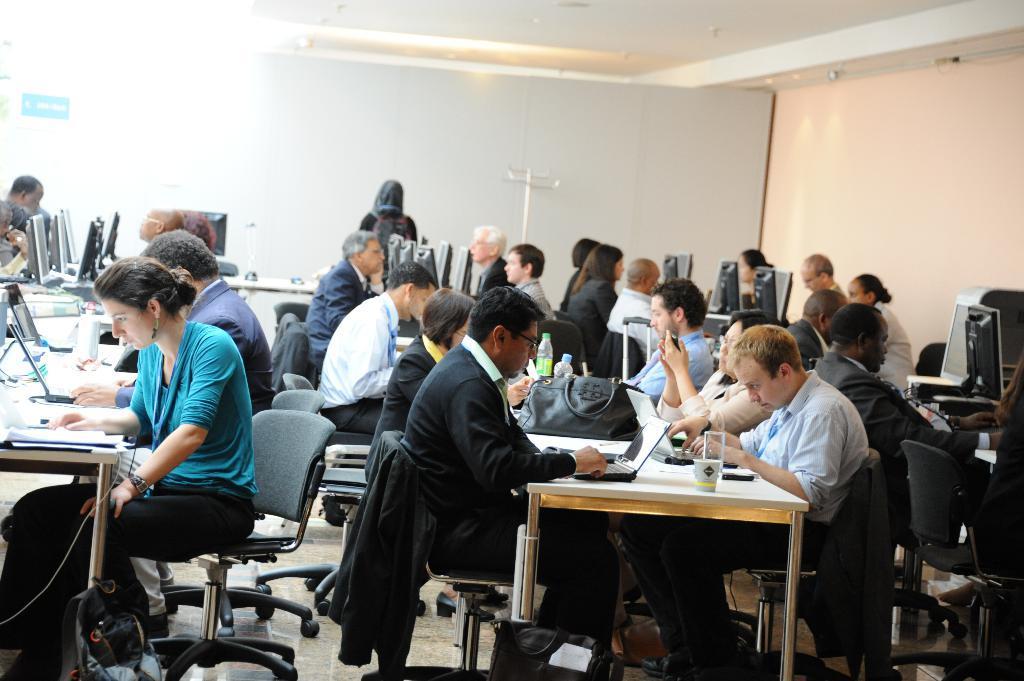How would you summarize this image in a sentence or two? Here, we see many people sitting on the chair and working in laptops and systems. The woman in blue t-shirt and black pant is looking into the papers. We find many chairs over here. The grey color bag is placed near the table. Here, we find many tables on which many systems and laptops were placed. We even find water bottles and handbags and glasses on this table. Behind these people, we find a wall which is white in color. 